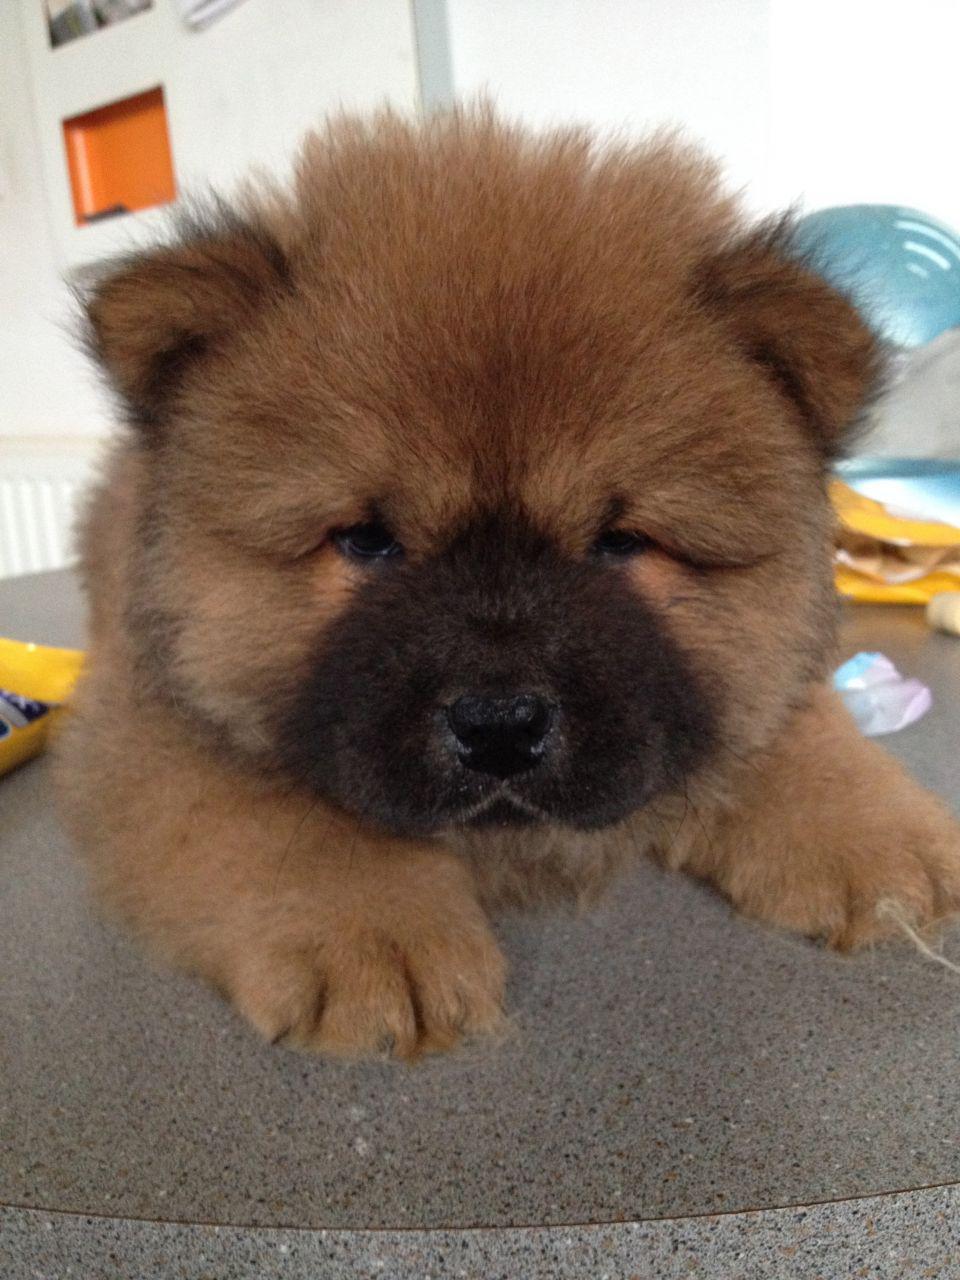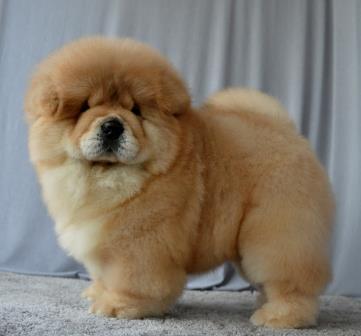The first image is the image on the left, the second image is the image on the right. Given the left and right images, does the statement "All dogs shown are chow puppies, one puppy is standing with its body in profile, one puppy has its front paws extended, and at least one of the puppies has a black muzzle." hold true? Answer yes or no. Yes. The first image is the image on the left, the second image is the image on the right. Given the left and right images, does the statement "The dog in the image on the right is positioned on a wooden surface." hold true? Answer yes or no. No. 